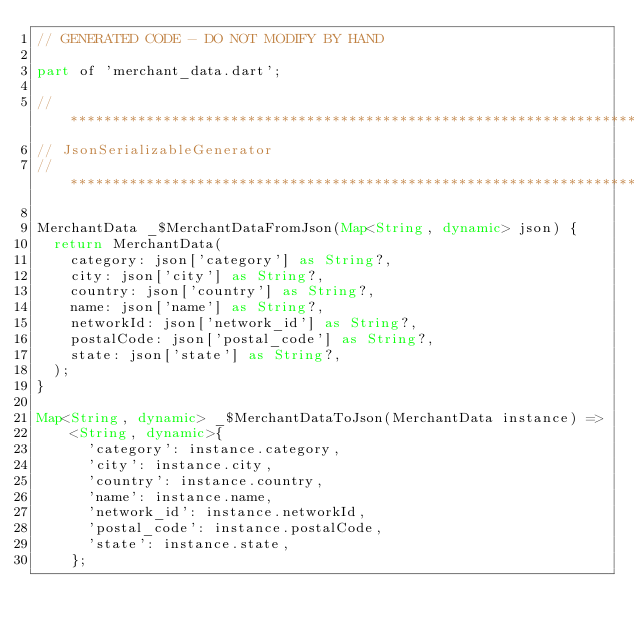Convert code to text. <code><loc_0><loc_0><loc_500><loc_500><_Dart_>// GENERATED CODE - DO NOT MODIFY BY HAND

part of 'merchant_data.dart';

// **************************************************************************
// JsonSerializableGenerator
// **************************************************************************

MerchantData _$MerchantDataFromJson(Map<String, dynamic> json) {
  return MerchantData(
    category: json['category'] as String?,
    city: json['city'] as String?,
    country: json['country'] as String?,
    name: json['name'] as String?,
    networkId: json['network_id'] as String?,
    postalCode: json['postal_code'] as String?,
    state: json['state'] as String?,
  );
}

Map<String, dynamic> _$MerchantDataToJson(MerchantData instance) =>
    <String, dynamic>{
      'category': instance.category,
      'city': instance.city,
      'country': instance.country,
      'name': instance.name,
      'network_id': instance.networkId,
      'postal_code': instance.postalCode,
      'state': instance.state,
    };
</code> 